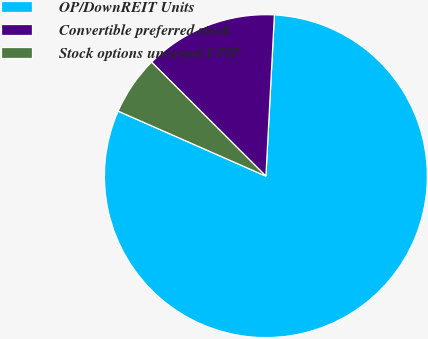<chart> <loc_0><loc_0><loc_500><loc_500><pie_chart><fcel>OP/DownREIT Units<fcel>Convertible preferred stock<fcel>Stock options unvested LTIP<nl><fcel>80.76%<fcel>13.36%<fcel>5.88%<nl></chart> 